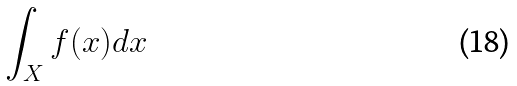<formula> <loc_0><loc_0><loc_500><loc_500>\int _ { X } f ( x ) d x</formula> 